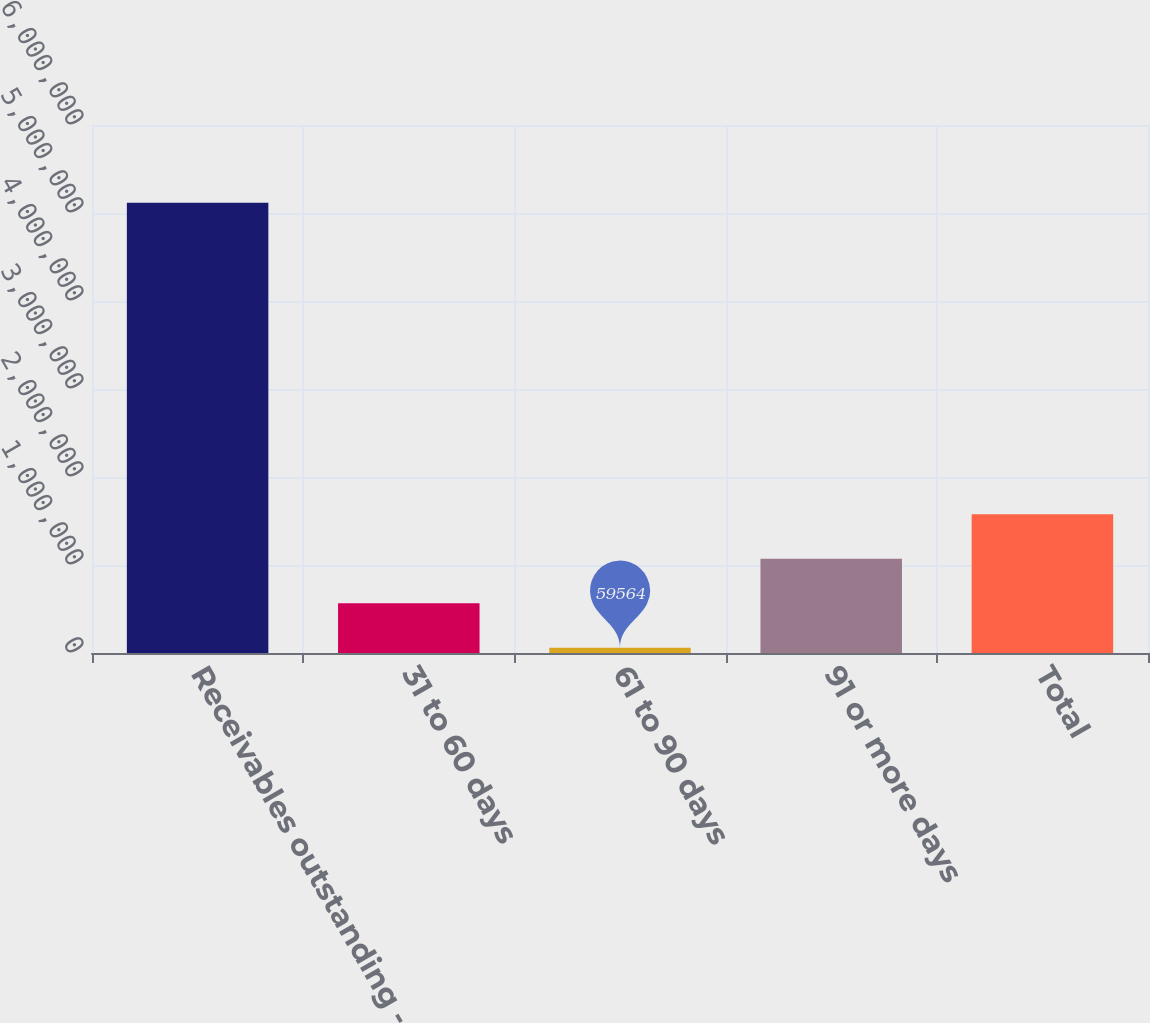<chart> <loc_0><loc_0><loc_500><loc_500><bar_chart><fcel>Receivables outstanding -<fcel>31 to 60 days<fcel>61 to 90 days<fcel>91 or more days<fcel>Total<nl><fcel>5.11611e+06<fcel>565219<fcel>59564<fcel>1.07087e+06<fcel>1.57653e+06<nl></chart> 